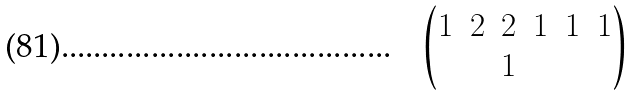Convert formula to latex. <formula><loc_0><loc_0><loc_500><loc_500>\begin{pmatrix} 1 & 2 & 2 & 1 & 1 & 1 \\ & & 1 & & & \end{pmatrix}</formula> 